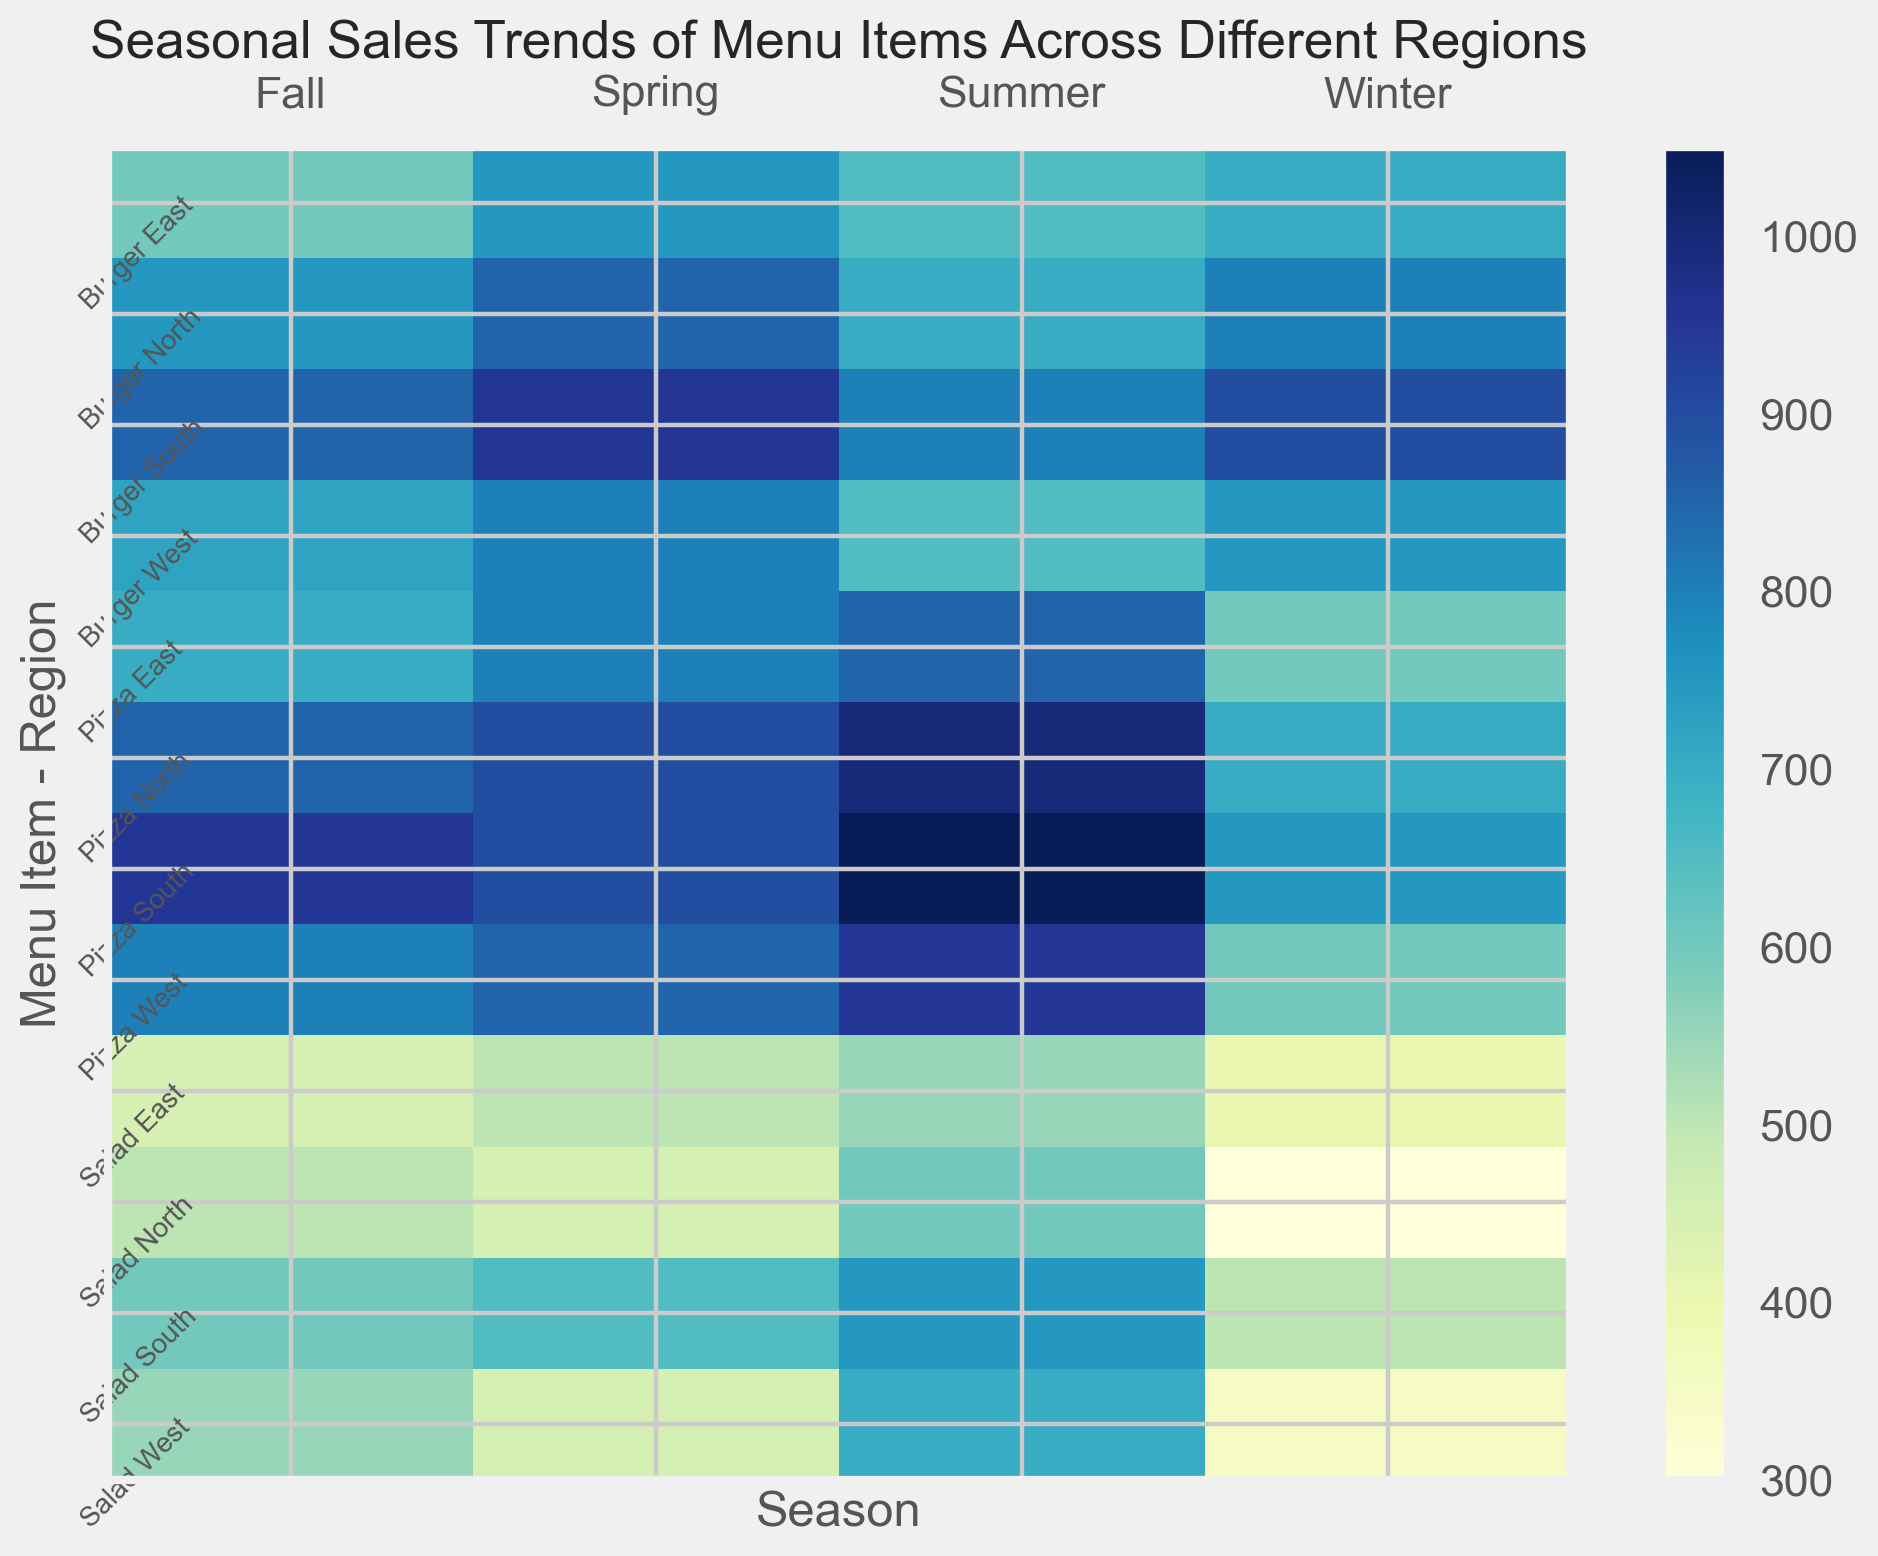Which region has the highest sales of burgers during winter? Look at the heatmap squares corresponding to "Burger Winter" across regions. Find the highest color intensity. The South region has the highest color intensity for burgers in winter.
Answer: South Is the seasonal trend for pizza sales the same across all regions? By comparing the colors representing each season for pizza across regions, observe any disparities or similar patterns in color intensity. We see different color patterns per region, suggesting varied seasonal trends.
Answer: No Which menu item shows the most consistent sales across all seasons in the East region? Examine the color intensity consistency for each menu item in the East region across seasons. A consistent color pattern indicates stable sales. Salad shows the most consistent color intensity.
Answer: Salad What's the average summer sales of pizzas across all regions? Identify the color intensities for "Pizza Summer" from all regions (North, South, East, West). Sum these values and divide by the number of regions (4). For fractions: (1000 + 1050 + 850 + 950) / 4 = 960.
Answer: 960 Does the West region have higher burger sales in spring or in fall? Compare the color intensity for "Burger Spring" and "Burger Fall" within the West region. The fall has a slightly darker color, indicating higher sales.
Answer: Fall Which region has the lowest salad sales in winter? Observe the colors for "Salad Winter" across all regions. The lightest color indicates the lowest sales. The West region has the lightest color.
Answer: West Is there a sharper increase in sales from winter to spring or from summer to fall for pizzas in the North region? Compare the color shift from winter to spring and from summer to fall for "Pizza North." The shift in color from spring to summer is larger.
Answer: Summer to Fall How do summer sales of burgers in the North region compare to those in the East region? Look at the color intensities for "Burger Summer" in both North and East regions. The Northern region shows a darker intensity compared to the Eastern region.
Answer: North What's the sum of salad sales in the South region for spring and fall? Find the values for "Salad Spring" and "Salad Fall" in the South region. Sum these values: 650 + 600 = 1250.
Answer: 1250 